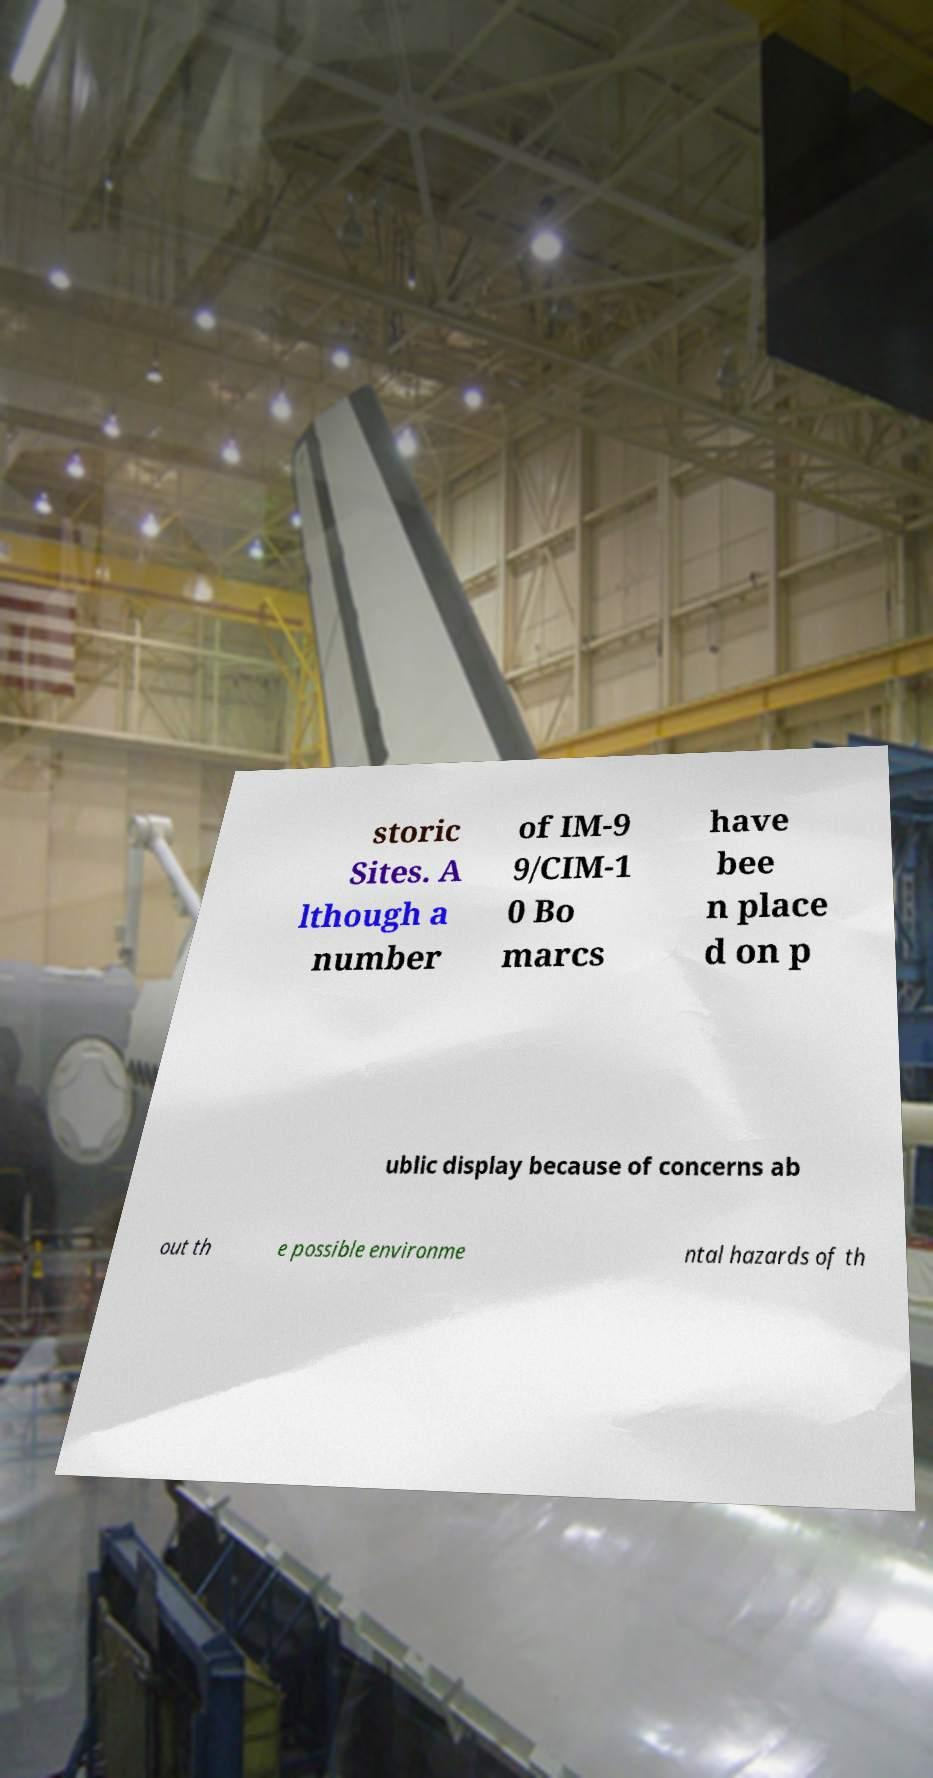I need the written content from this picture converted into text. Can you do that? storic Sites. A lthough a number of IM-9 9/CIM-1 0 Bo marcs have bee n place d on p ublic display because of concerns ab out th e possible environme ntal hazards of th 